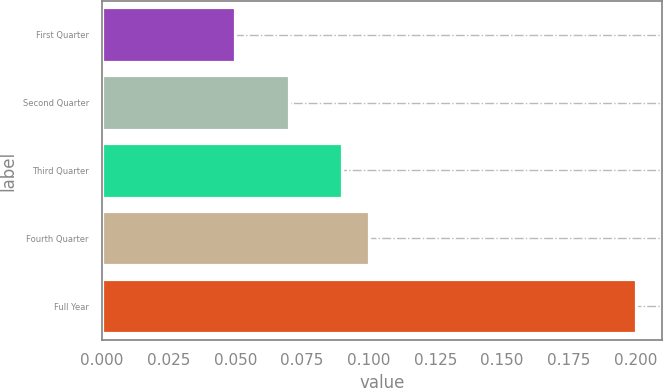Convert chart to OTSL. <chart><loc_0><loc_0><loc_500><loc_500><bar_chart><fcel>First Quarter<fcel>Second Quarter<fcel>Third Quarter<fcel>Fourth Quarter<fcel>Full Year<nl><fcel>0.05<fcel>0.07<fcel>0.09<fcel>0.1<fcel>0.2<nl></chart> 